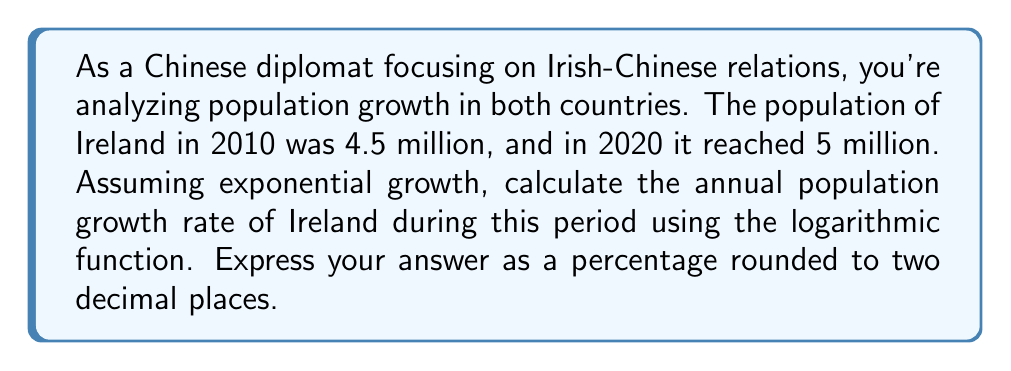Could you help me with this problem? Let's approach this step-by-step using the exponential growth formula and logarithms:

1) The exponential growth formula is:
   $$A = P(1 + r)^t$$
   Where:
   $A$ is the final amount
   $P$ is the initial amount
   $r$ is the annual growth rate
   $t$ is the time in years

2) We know:
   $P = 4.5$ million (2010 population)
   $A = 5$ million (2020 population)
   $t = 10$ years

3) Substituting these values:
   $$5 = 4.5(1 + r)^{10}$$

4) Divide both sides by 4.5:
   $$\frac{5}{4.5} = (1 + r)^{10}$$

5) Take the natural logarithm of both sides:
   $$\ln(\frac{5}{4.5}) = \ln((1 + r)^{10})$$

6) Using the logarithm property $\ln(x^n) = n\ln(x)$:
   $$\ln(\frac{5}{4.5}) = 10\ln(1 + r)$$

7) Divide both sides by 10:
   $$\frac{\ln(\frac{5}{4.5})}{10} = \ln(1 + r)$$

8) Take $e$ to the power of both sides:
   $$e^{\frac{\ln(\frac{5}{4.5})}{10}} = e^{\ln(1 + r)} = 1 + r$$

9) Subtract 1 from both sides:
   $$e^{\frac{\ln(\frac{5}{4.5})}{10}} - 1 = r$$

10) Calculate:
    $$r = e^{\frac{\ln(\frac{5}{4.5})}{10}} - 1 \approx 0.0106$$

11) Convert to percentage:
    $$0.0106 \times 100\% = 1.06\%$$
Answer: 1.06% 